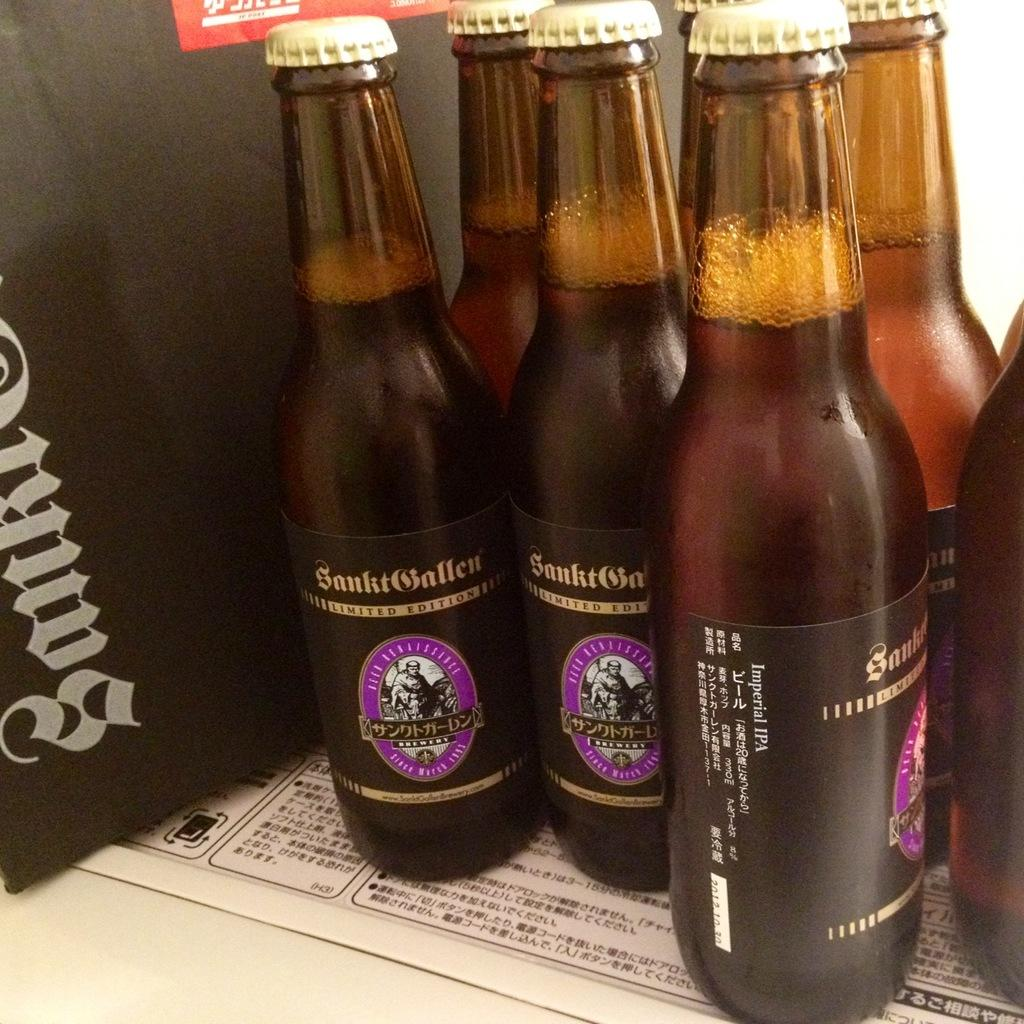<image>
Describe the image concisely. Bottles of a limited edition beer are on a shelf together 